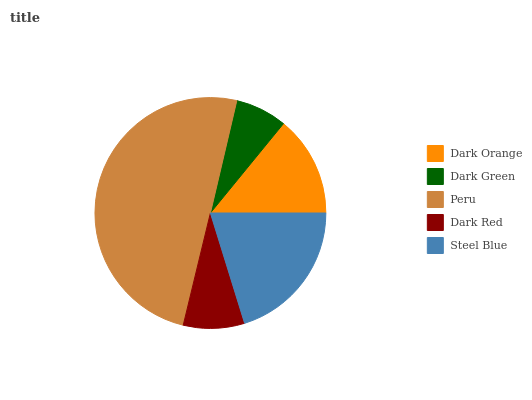Is Dark Green the minimum?
Answer yes or no. Yes. Is Peru the maximum?
Answer yes or no. Yes. Is Peru the minimum?
Answer yes or no. No. Is Dark Green the maximum?
Answer yes or no. No. Is Peru greater than Dark Green?
Answer yes or no. Yes. Is Dark Green less than Peru?
Answer yes or no. Yes. Is Dark Green greater than Peru?
Answer yes or no. No. Is Peru less than Dark Green?
Answer yes or no. No. Is Dark Orange the high median?
Answer yes or no. Yes. Is Dark Orange the low median?
Answer yes or no. Yes. Is Peru the high median?
Answer yes or no. No. Is Peru the low median?
Answer yes or no. No. 